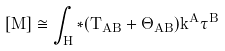Convert formula to latex. <formula><loc_0><loc_0><loc_500><loc_500>[ M ] \cong \int _ { H } \hat { * } ( T _ { A B } + \Theta _ { A B } ) k ^ { A } \hat { \tau } ^ { B }</formula> 